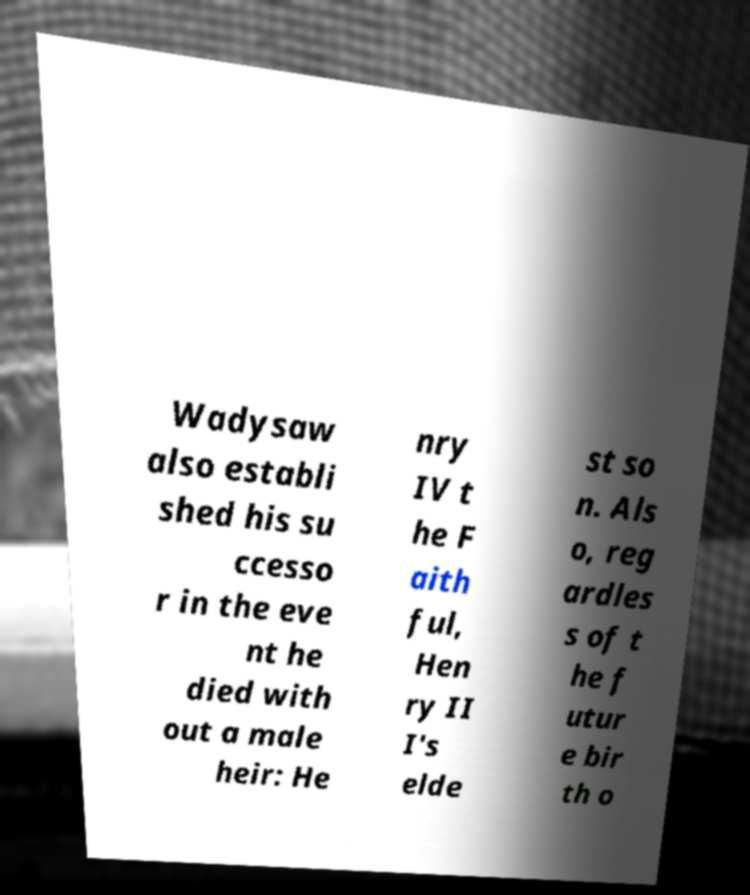There's text embedded in this image that I need extracted. Can you transcribe it verbatim? Wadysaw also establi shed his su ccesso r in the eve nt he died with out a male heir: He nry IV t he F aith ful, Hen ry II I's elde st so n. Als o, reg ardles s of t he f utur e bir th o 